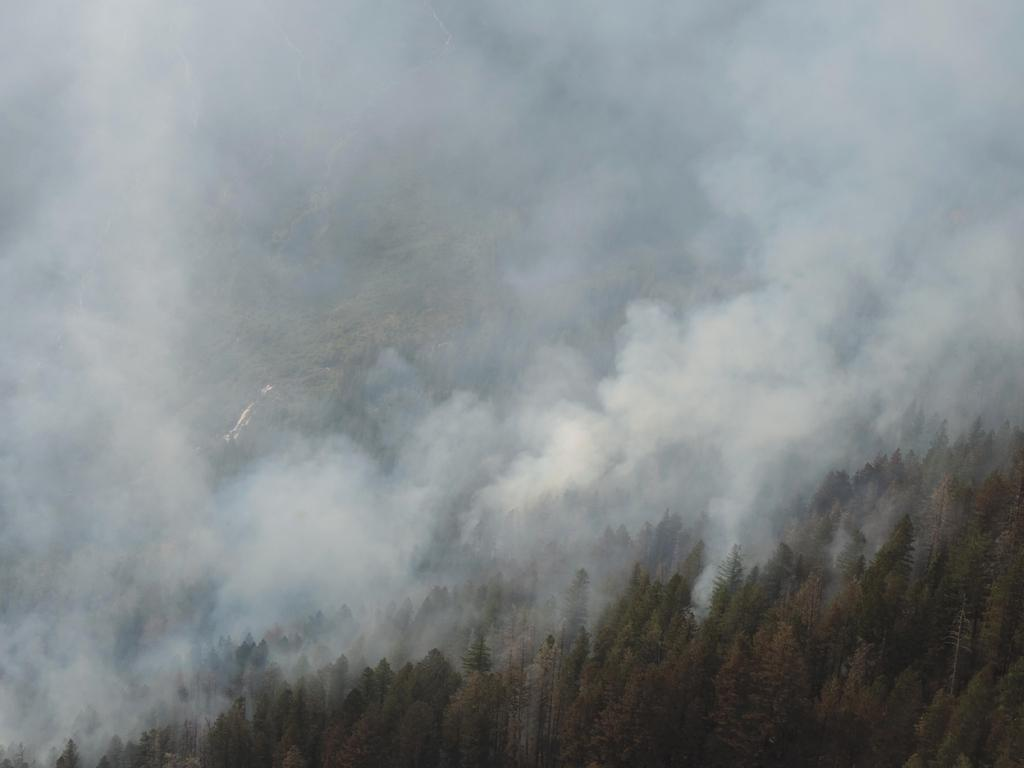What type of vegetation can be seen in the image? There are trees in the image. What else is visible in the image besides the trees? There is smoke visible in the image. What grade does the arithmetic problem in the image receive? There is no arithmetic problem present in the image, so it cannot receive a grade. 